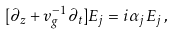<formula> <loc_0><loc_0><loc_500><loc_500>[ \partial _ { z } + v _ { g } ^ { - 1 } \partial _ { t } ] E _ { j } = i \alpha _ { j } E _ { j } \, ,</formula> 